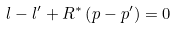<formula> <loc_0><loc_0><loc_500><loc_500>l - l ^ { \prime } + R ^ { \ast } \left ( p - p ^ { \prime } \right ) = 0</formula> 